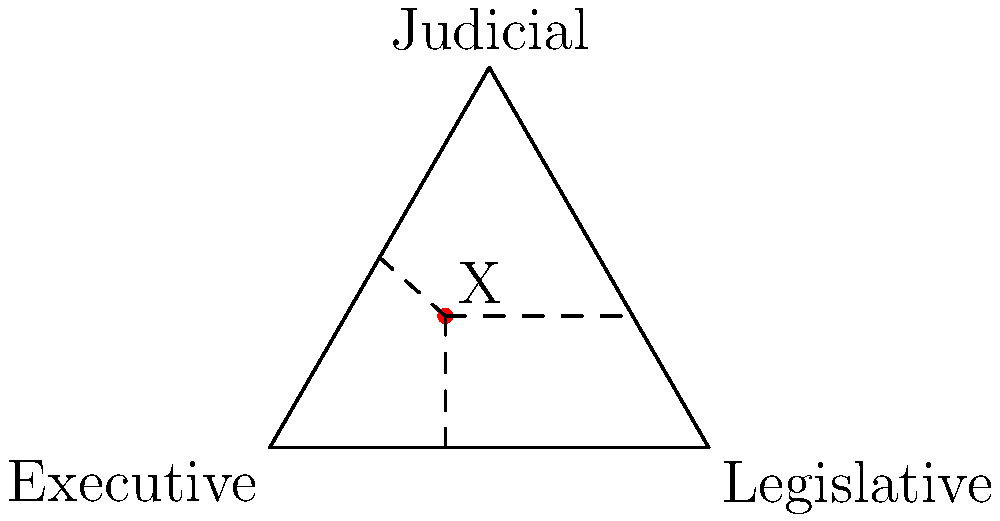In the triangular coordinate system representing the balance of power among the three branches of government (Executive, Legislative, and Judicial), a point X is marked. Based on its position, which branch appears to have the most influence in this particular power distribution? To determine which branch has the most influence based on the position of point X, we need to follow these steps:

1. Understand the coordinate system:
   - Each corner of the triangle represents 100% power for that branch.
   - The closer a point is to a corner, the more power that branch has.

2. Analyze the position of point X:
   - X appears to be closest to the "Executive" corner.
   - It's somewhat far from the "Judicial" corner.
   - It's at a moderate distance from the "Legislative" corner.

3. Compare the distances:
   - The shortest perpendicular line from X is to the side opposite the "Executive" corner.
   - This indicates that the Executive branch has the most influence in this configuration.

4. Historical context:
   - This type of power distribution might occur during times of national crisis or when a strong executive is in office.
   - Examples in U.S. history include Franklin D. Roosevelt's presidency during the Great Depression and World War II, or George W. Bush's presidency following 9/11.

5. Implications:
   - A strong executive can lead to quicker decision-making but may raise concerns about checks and balances.
   - This situation often prompts discussions about the separation of powers and constitutional limits on executive authority.

Based on this analysis, the Executive branch appears to have the most influence in the power distribution represented by point X.
Answer: Executive branch 